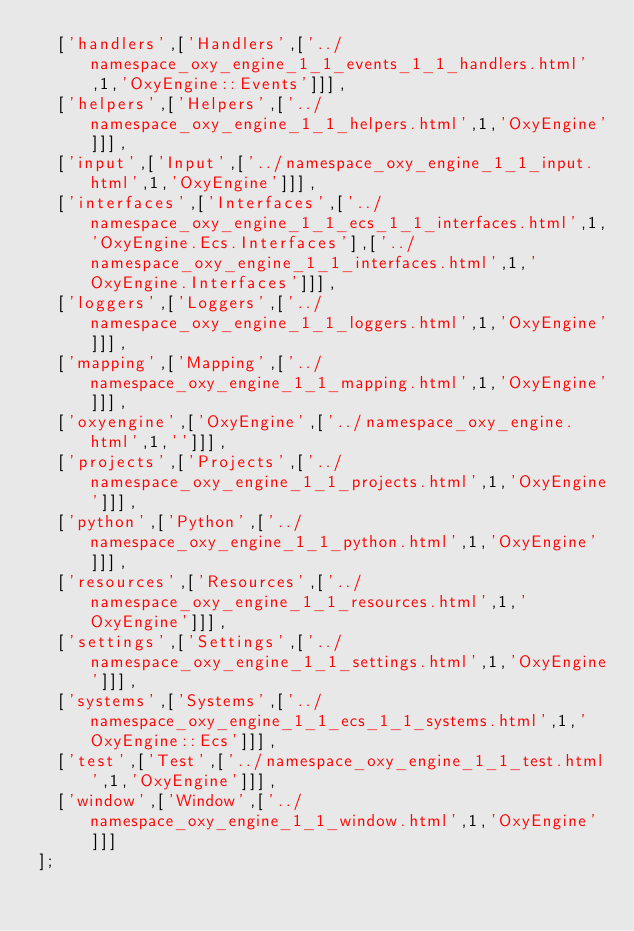<code> <loc_0><loc_0><loc_500><loc_500><_JavaScript_>  ['handlers',['Handlers',['../namespace_oxy_engine_1_1_events_1_1_handlers.html',1,'OxyEngine::Events']]],
  ['helpers',['Helpers',['../namespace_oxy_engine_1_1_helpers.html',1,'OxyEngine']]],
  ['input',['Input',['../namespace_oxy_engine_1_1_input.html',1,'OxyEngine']]],
  ['interfaces',['Interfaces',['../namespace_oxy_engine_1_1_ecs_1_1_interfaces.html',1,'OxyEngine.Ecs.Interfaces'],['../namespace_oxy_engine_1_1_interfaces.html',1,'OxyEngine.Interfaces']]],
  ['loggers',['Loggers',['../namespace_oxy_engine_1_1_loggers.html',1,'OxyEngine']]],
  ['mapping',['Mapping',['../namespace_oxy_engine_1_1_mapping.html',1,'OxyEngine']]],
  ['oxyengine',['OxyEngine',['../namespace_oxy_engine.html',1,'']]],
  ['projects',['Projects',['../namespace_oxy_engine_1_1_projects.html',1,'OxyEngine']]],
  ['python',['Python',['../namespace_oxy_engine_1_1_python.html',1,'OxyEngine']]],
  ['resources',['Resources',['../namespace_oxy_engine_1_1_resources.html',1,'OxyEngine']]],
  ['settings',['Settings',['../namespace_oxy_engine_1_1_settings.html',1,'OxyEngine']]],
  ['systems',['Systems',['../namespace_oxy_engine_1_1_ecs_1_1_systems.html',1,'OxyEngine::Ecs']]],
  ['test',['Test',['../namespace_oxy_engine_1_1_test.html',1,'OxyEngine']]],
  ['window',['Window',['../namespace_oxy_engine_1_1_window.html',1,'OxyEngine']]]
];
</code> 